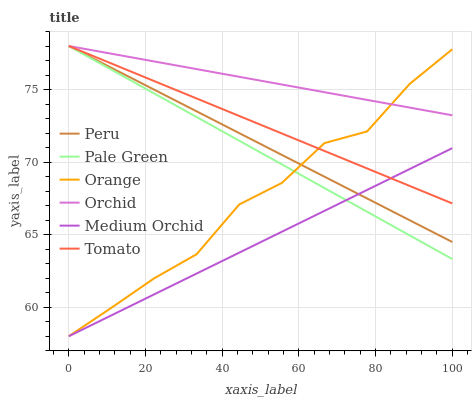Does Medium Orchid have the minimum area under the curve?
Answer yes or no. Yes. Does Orchid have the maximum area under the curve?
Answer yes or no. Yes. Does Pale Green have the minimum area under the curve?
Answer yes or no. No. Does Pale Green have the maximum area under the curve?
Answer yes or no. No. Is Orchid the smoothest?
Answer yes or no. Yes. Is Orange the roughest?
Answer yes or no. Yes. Is Medium Orchid the smoothest?
Answer yes or no. No. Is Medium Orchid the roughest?
Answer yes or no. No. Does Medium Orchid have the lowest value?
Answer yes or no. Yes. Does Pale Green have the lowest value?
Answer yes or no. No. Does Orchid have the highest value?
Answer yes or no. Yes. Does Medium Orchid have the highest value?
Answer yes or no. No. Is Medium Orchid less than Orchid?
Answer yes or no. Yes. Is Orchid greater than Medium Orchid?
Answer yes or no. Yes. Does Tomato intersect Peru?
Answer yes or no. Yes. Is Tomato less than Peru?
Answer yes or no. No. Is Tomato greater than Peru?
Answer yes or no. No. Does Medium Orchid intersect Orchid?
Answer yes or no. No. 